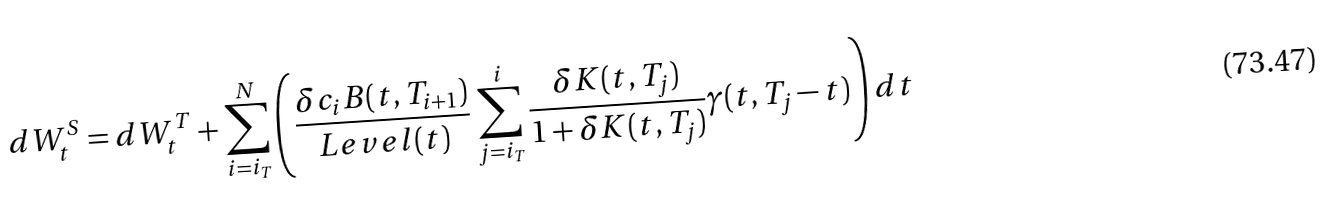<formula> <loc_0><loc_0><loc_500><loc_500>d W _ { t } ^ { S } = d W _ { t } ^ { T } + \sum _ { i = i _ { T } } ^ { N } \left ( \frac { \delta c _ { i } B ( t , T _ { i + 1 } ) } { L e v e l ( t ) } \sum _ { j = i _ { T } } ^ { i } \frac { \delta K ( t , T _ { j } ) } { 1 + \delta K ( t , T _ { j } ) } \gamma ( t , T _ { j } - t ) \right ) d t</formula> 